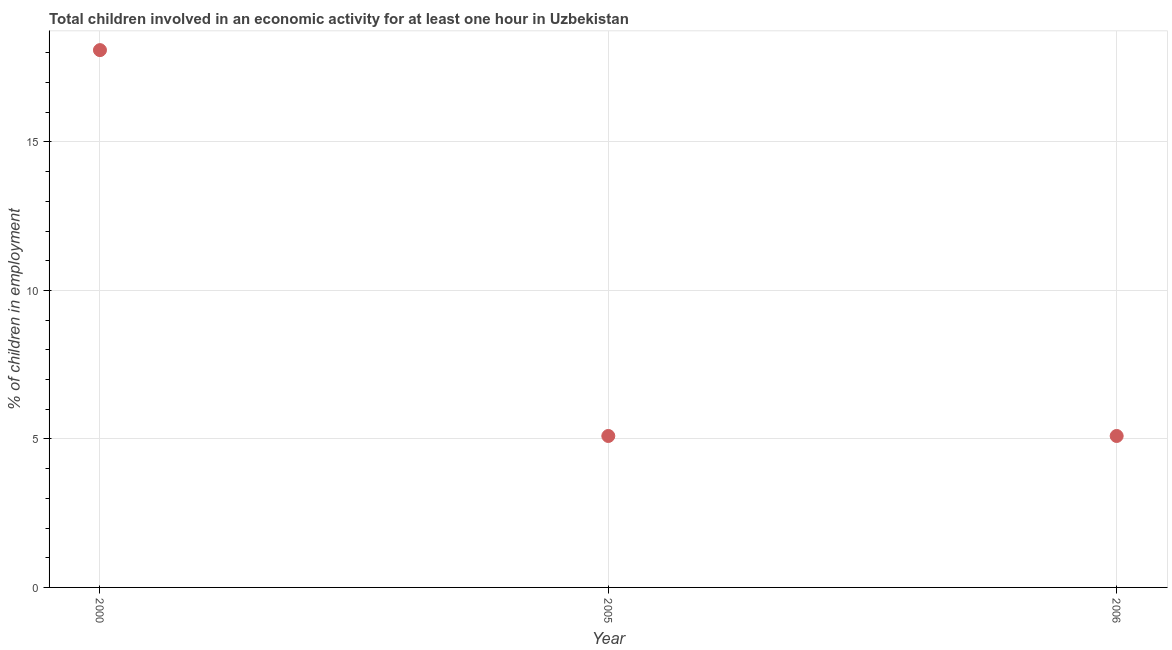Across all years, what is the maximum percentage of children in employment?
Ensure brevity in your answer.  18.09. Across all years, what is the minimum percentage of children in employment?
Ensure brevity in your answer.  5.1. In which year was the percentage of children in employment minimum?
Offer a terse response. 2005. What is the sum of the percentage of children in employment?
Keep it short and to the point. 28.29. What is the average percentage of children in employment per year?
Give a very brief answer. 9.43. What is the median percentage of children in employment?
Keep it short and to the point. 5.1. In how many years, is the percentage of children in employment greater than 2 %?
Provide a short and direct response. 3. Do a majority of the years between 2006 and 2005 (inclusive) have percentage of children in employment greater than 14 %?
Offer a very short reply. No. What is the ratio of the percentage of children in employment in 2000 to that in 2005?
Provide a short and direct response. 3.55. Is the percentage of children in employment in 2000 less than that in 2006?
Provide a succinct answer. No. Is the difference between the percentage of children in employment in 2005 and 2006 greater than the difference between any two years?
Keep it short and to the point. No. What is the difference between the highest and the second highest percentage of children in employment?
Your answer should be very brief. 12.99. What is the difference between the highest and the lowest percentage of children in employment?
Your answer should be compact. 12.99. In how many years, is the percentage of children in employment greater than the average percentage of children in employment taken over all years?
Ensure brevity in your answer.  1. Does the percentage of children in employment monotonically increase over the years?
Provide a succinct answer. No. What is the difference between two consecutive major ticks on the Y-axis?
Your answer should be compact. 5. Are the values on the major ticks of Y-axis written in scientific E-notation?
Keep it short and to the point. No. Does the graph contain grids?
Make the answer very short. Yes. What is the title of the graph?
Ensure brevity in your answer.  Total children involved in an economic activity for at least one hour in Uzbekistan. What is the label or title of the Y-axis?
Offer a terse response. % of children in employment. What is the % of children in employment in 2000?
Make the answer very short. 18.09. What is the difference between the % of children in employment in 2000 and 2005?
Offer a terse response. 12.99. What is the difference between the % of children in employment in 2000 and 2006?
Your answer should be very brief. 12.99. What is the ratio of the % of children in employment in 2000 to that in 2005?
Keep it short and to the point. 3.55. What is the ratio of the % of children in employment in 2000 to that in 2006?
Offer a very short reply. 3.55. What is the ratio of the % of children in employment in 2005 to that in 2006?
Offer a very short reply. 1. 